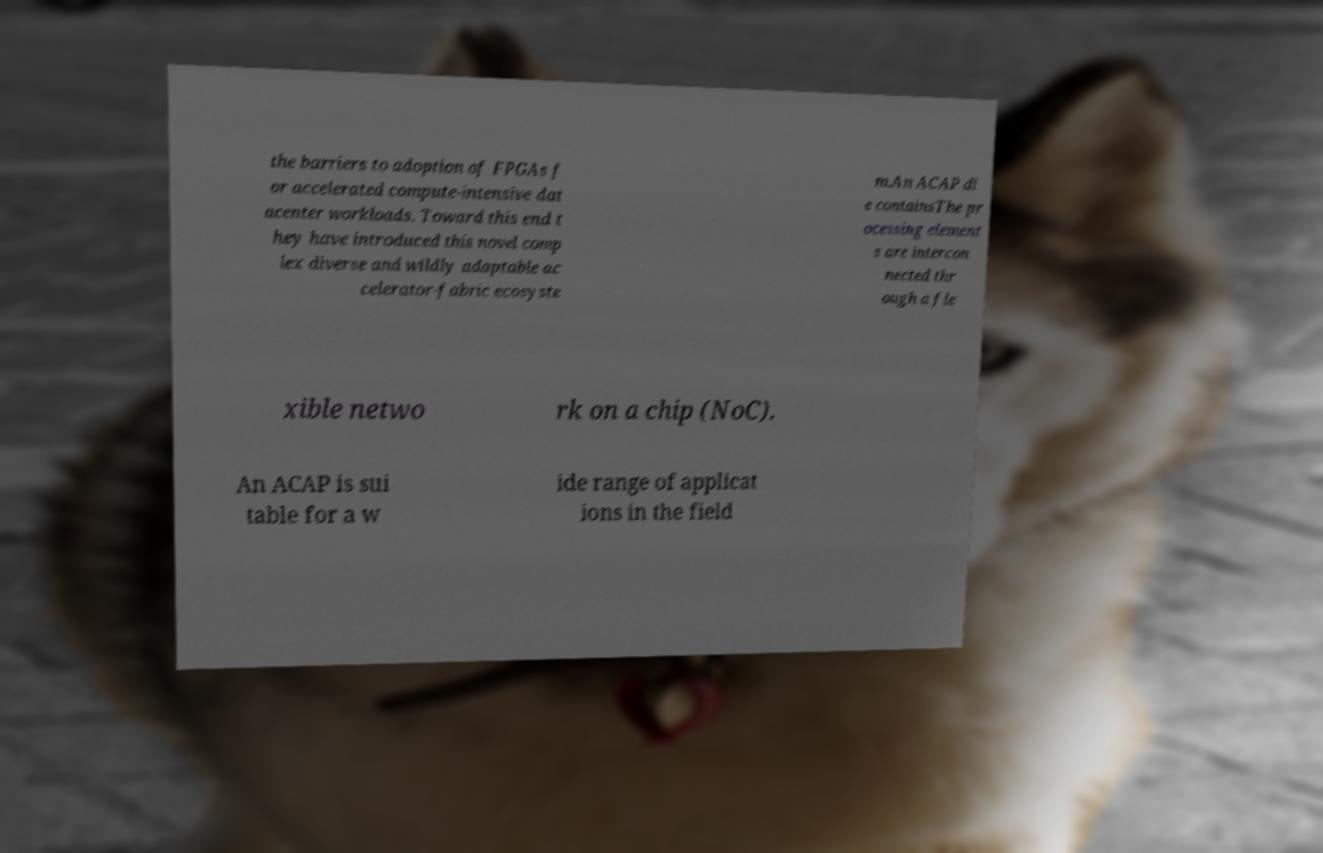Please read and relay the text visible in this image. What does it say? the barriers to adoption of FPGAs f or accelerated compute-intensive dat acenter workloads. Toward this end t hey have introduced this novel comp lex diverse and wildly adaptable ac celerator-fabric ecosyste m.An ACAP di e containsThe pr ocessing element s are intercon nected thr ough a fle xible netwo rk on a chip (NoC). An ACAP is sui table for a w ide range of applicat ions in the field 